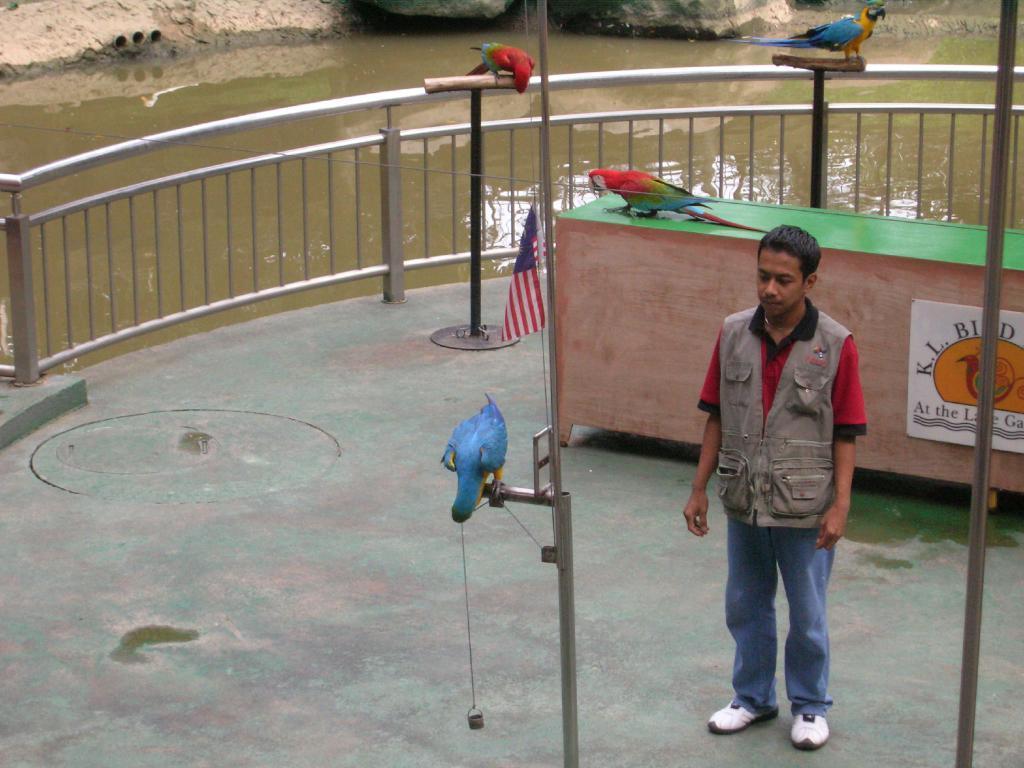Could you give a brief overview of what you see in this image? In this image there is a man standing on the ground. Behind him there is a table. There is a text on the table. There is a bird standing on the table. Beside the table there is a flag. In front of the man there are rods. There are birds on the railing. Around him there is a railing. Behind the railing there is the water. At the top there are rocks 